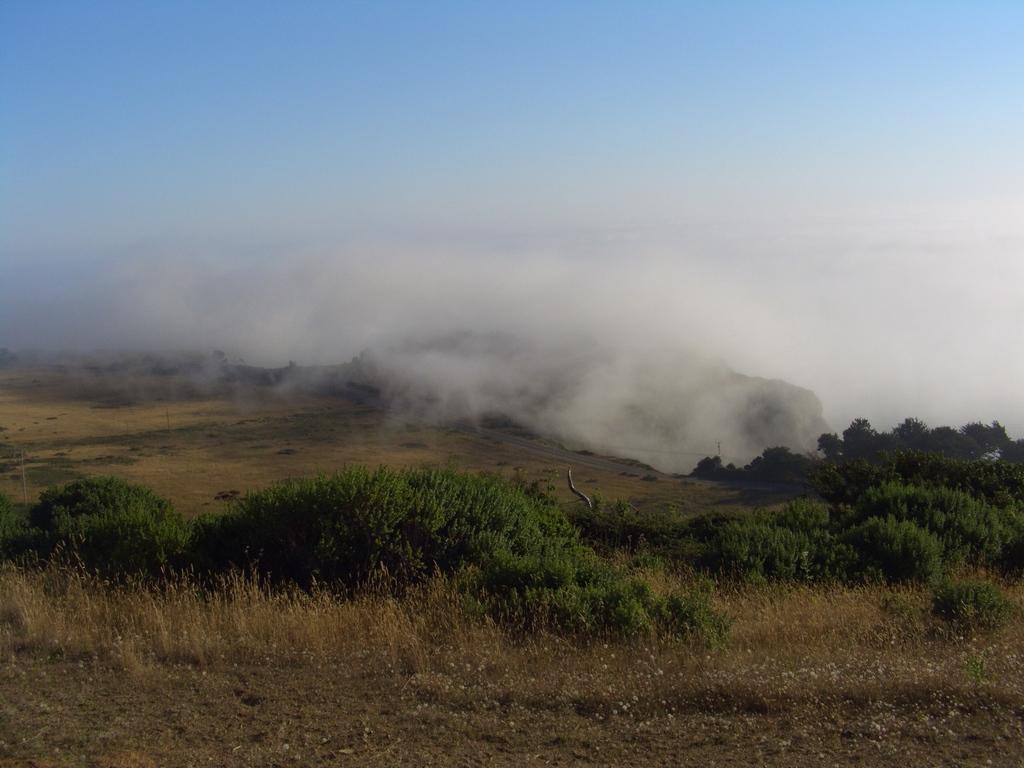How would you summarize this image in a sentence or two? In the picture we can see a grass surface on it, we can see some grass plants, plants and a fog and in the background we can see a sky. 